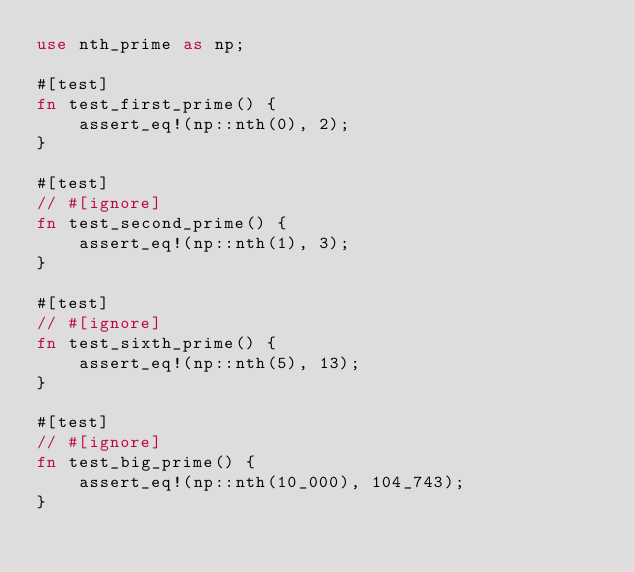Convert code to text. <code><loc_0><loc_0><loc_500><loc_500><_Rust_>use nth_prime as np;

#[test]
fn test_first_prime() {
    assert_eq!(np::nth(0), 2);
}

#[test]
// #[ignore]
fn test_second_prime() {
    assert_eq!(np::nth(1), 3);
}

#[test]
// #[ignore]
fn test_sixth_prime() {
    assert_eq!(np::nth(5), 13);
}

#[test]
// #[ignore]
fn test_big_prime() {
    assert_eq!(np::nth(10_000), 104_743);
}
</code> 